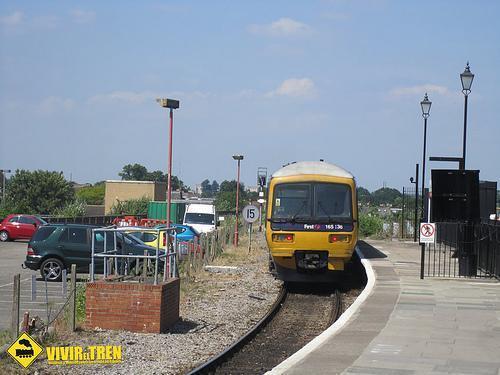How many lights are on the platform to the left of the train?
Give a very brief answer. 2. 